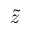Convert formula to latex. <formula><loc_0><loc_0><loc_500><loc_500>\tilde { z }</formula> 